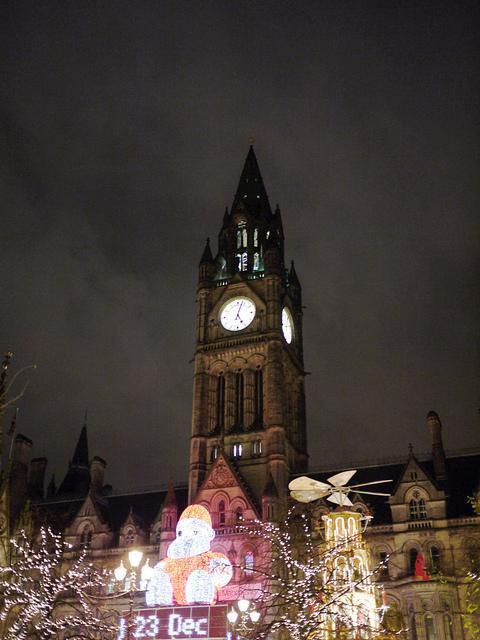How many people are wearing blue jeans?
Give a very brief answer. 0. 